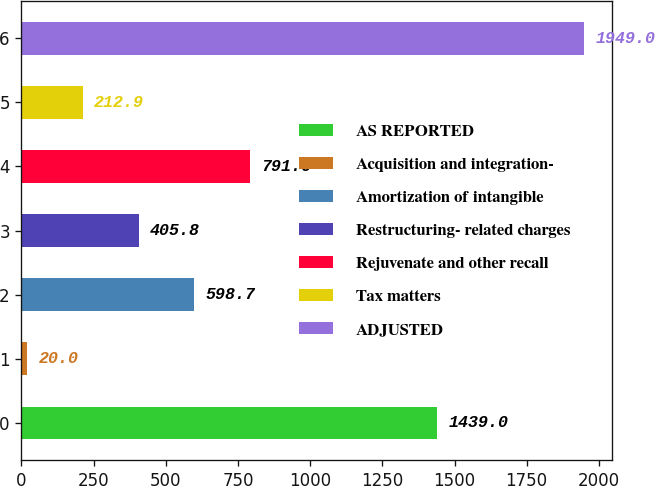Convert chart to OTSL. <chart><loc_0><loc_0><loc_500><loc_500><bar_chart><fcel>AS REPORTED<fcel>Acquisition and integration-<fcel>Amortization of intangible<fcel>Restructuring- related charges<fcel>Rejuvenate and other recall<fcel>Tax matters<fcel>ADJUSTED<nl><fcel>1439<fcel>20<fcel>598.7<fcel>405.8<fcel>791.6<fcel>212.9<fcel>1949<nl></chart> 